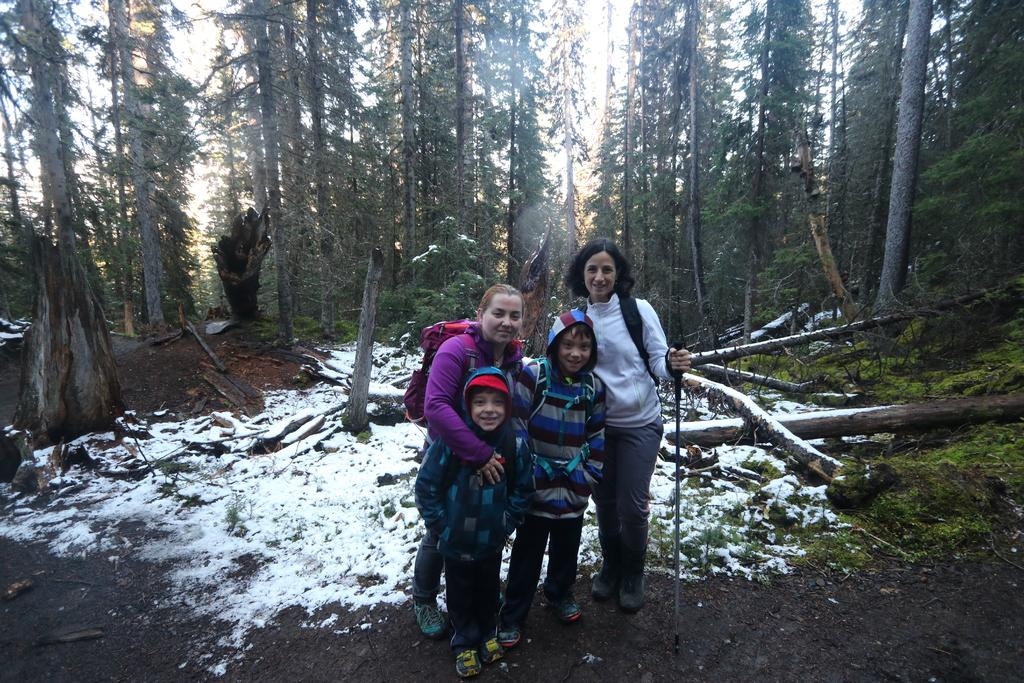How many people are in the image? There are four people in the image. What are the people doing in the image? The people are carrying bags and standing on the ground. What is the facial expression of the people in the image? The people are smiling. What is the weather like in the image? There is snow in the image, indicating a cold and likely wintery environment. What type of natural elements can be seen in the image? There are wooden logs and trees in the image. What is visible in the background of the image? The sky is visible in the background of the image. What game are the people playing in the image? There is no game being played in the image; the people are simply standing and carrying bags. Can you tell me what type of doctor is present in the image? There is no doctor present in the image. 